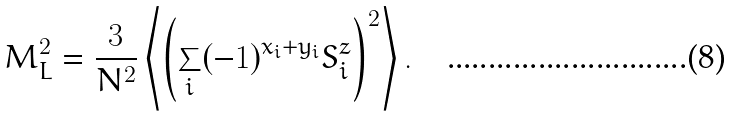<formula> <loc_0><loc_0><loc_500><loc_500>M _ { L } ^ { 2 } = \frac { 3 } { N ^ { 2 } } \left \langle \left ( \sum _ { i } ( - 1 ) ^ { x _ { i } + y _ { i } } S _ { i } ^ { z } \right ) ^ { 2 } \right \rangle .</formula> 